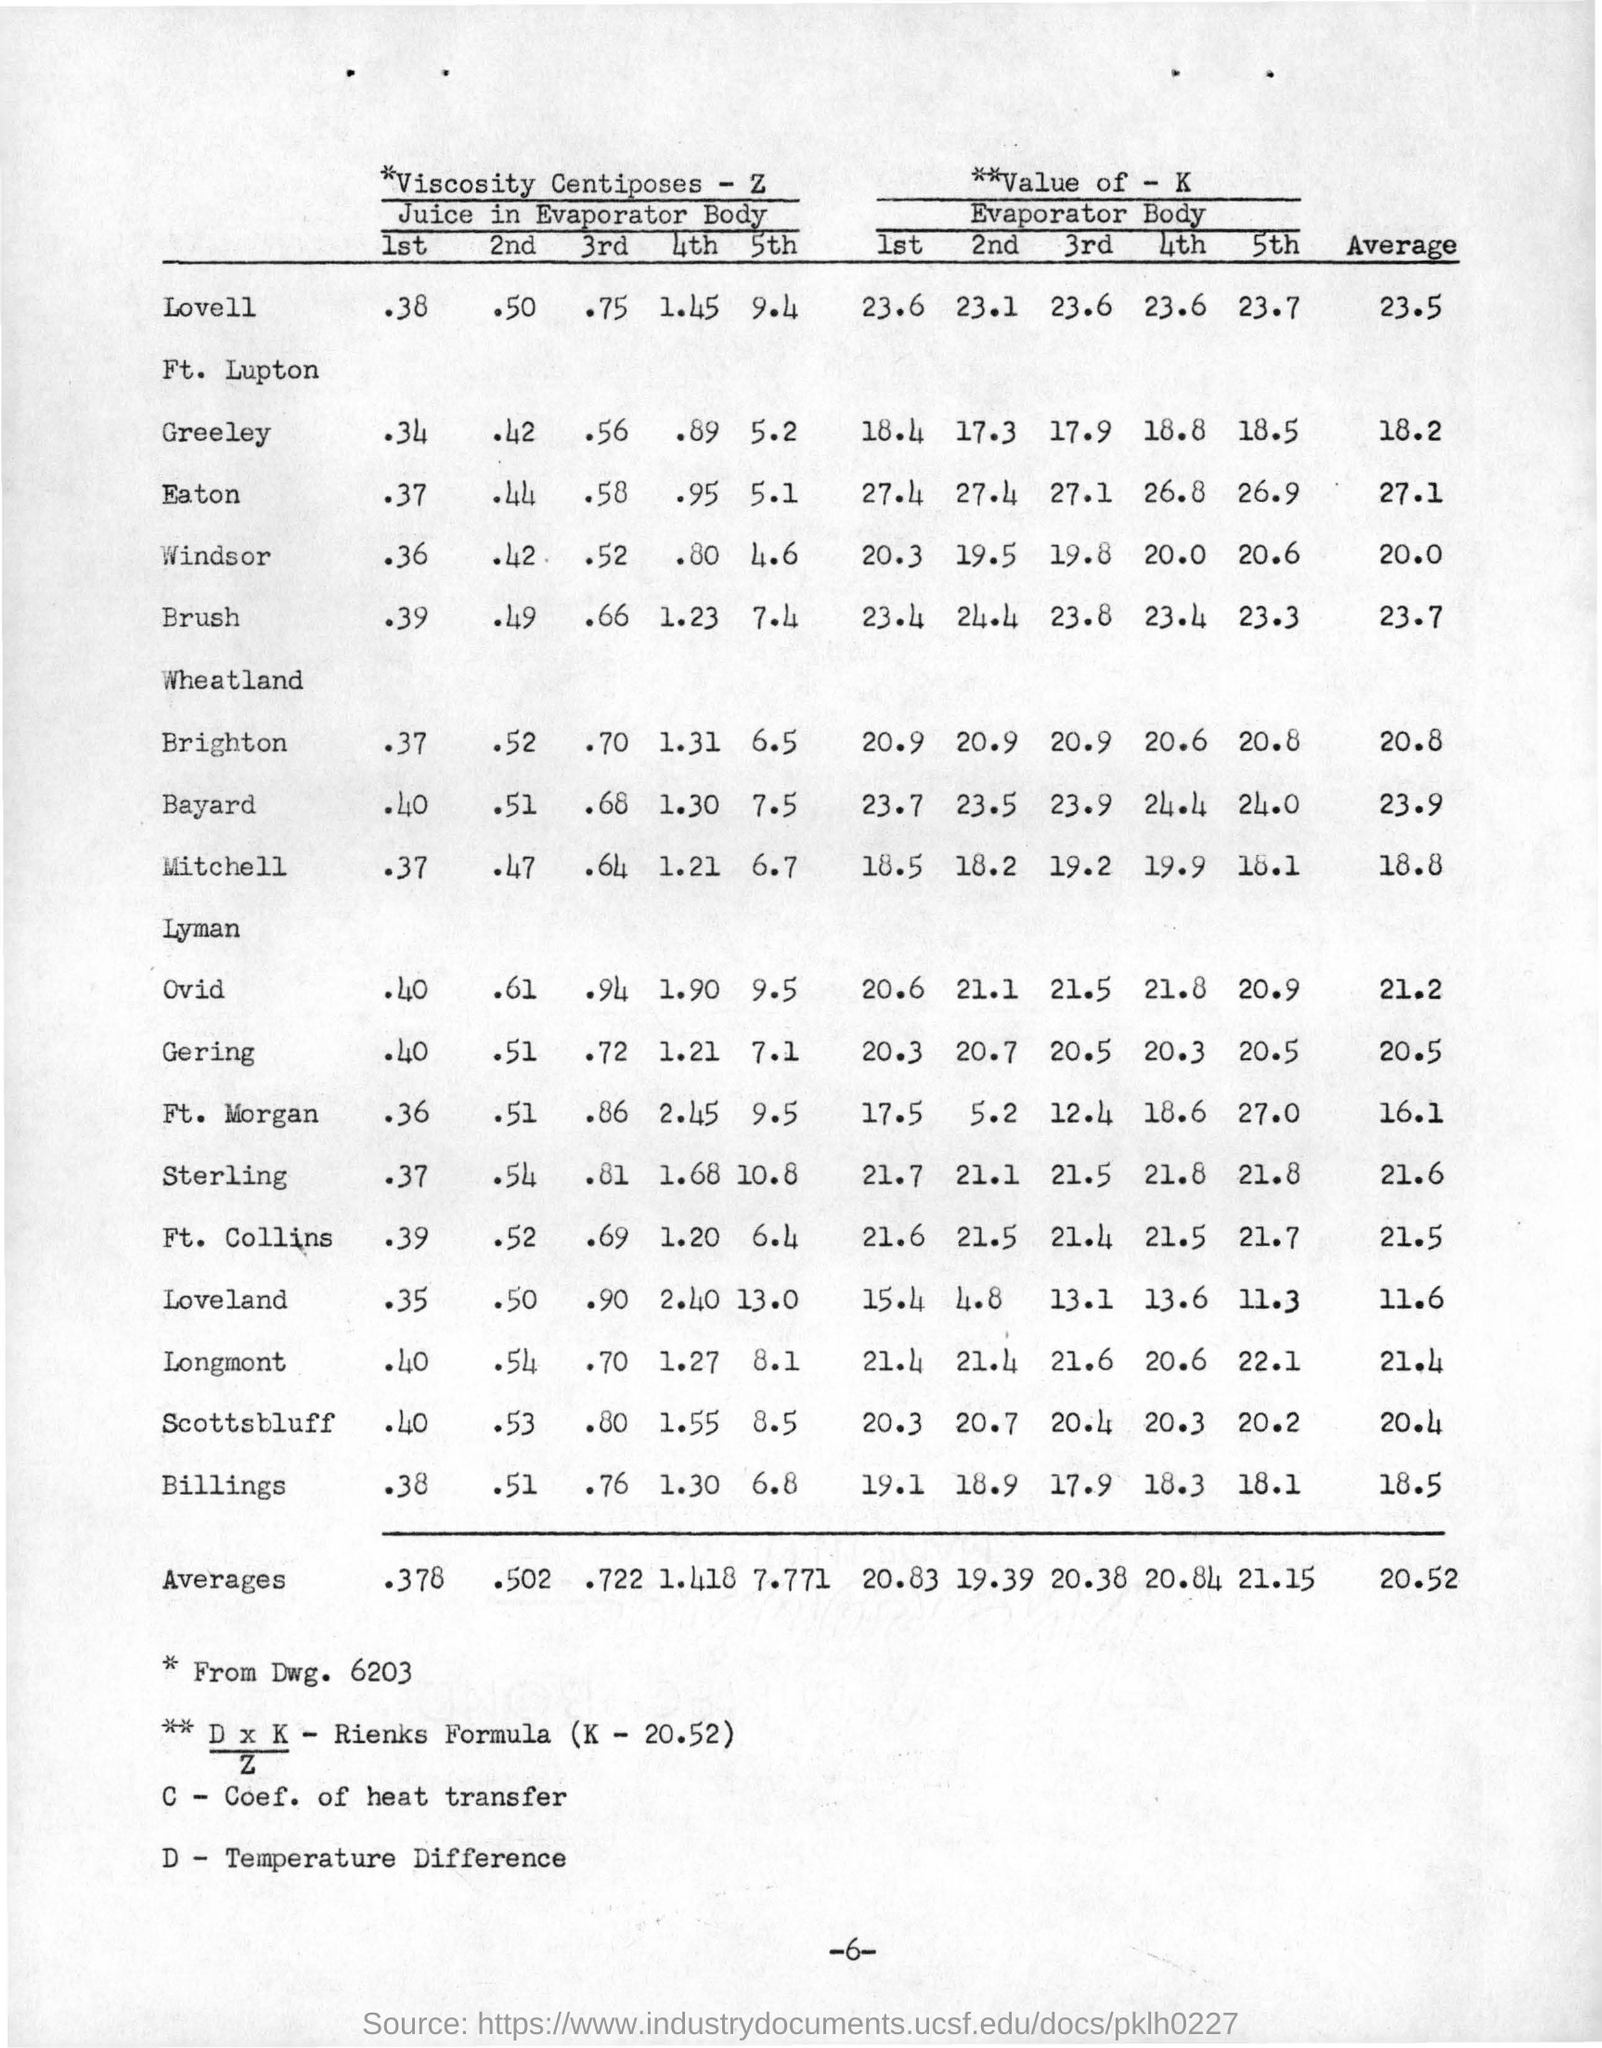What is the value of K in Rienks Formula?
Make the answer very short. 20.52. 